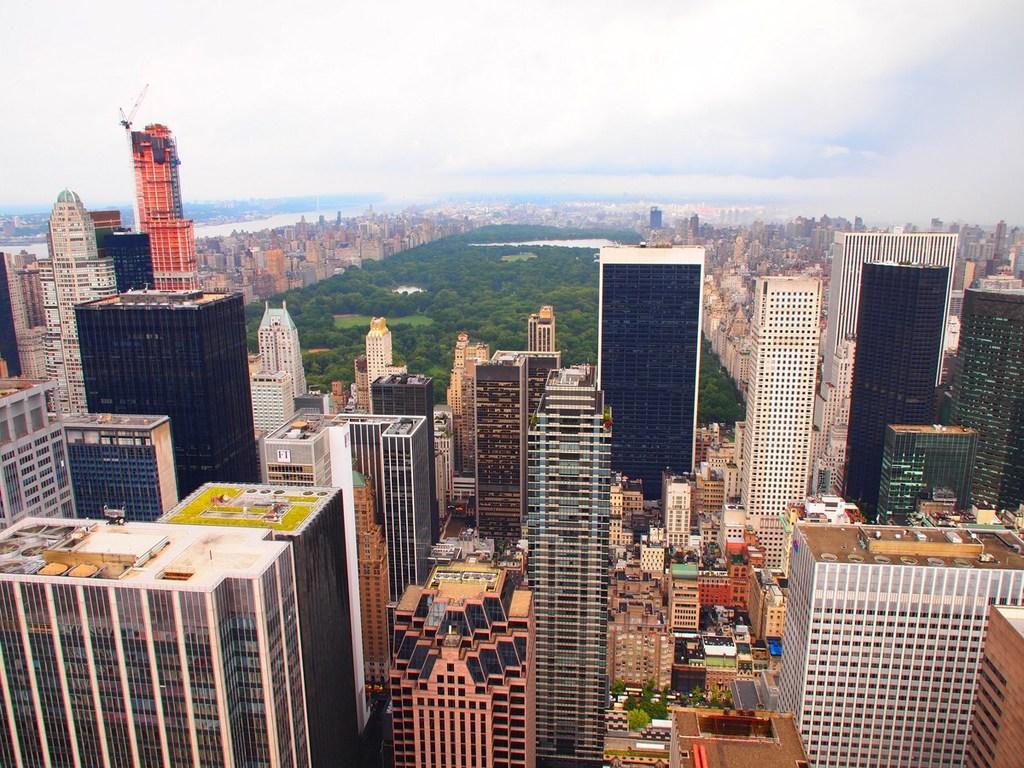Describe this image in one or two sentences. The picture is captured from a top view, there are a lot of tall buildings and behind those buildings there is some greenery and around the greenery also there are many buildings. 